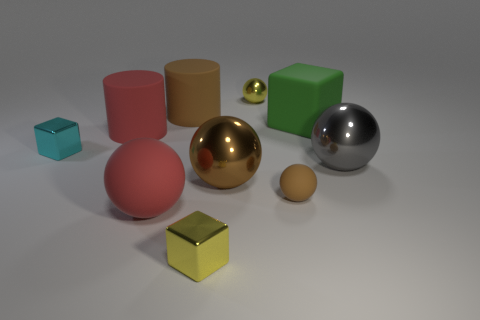Subtract 2 spheres. How many spheres are left? 3 Subtract all gray spheres. How many spheres are left? 4 Subtract all large matte balls. How many balls are left? 4 Subtract all purple balls. Subtract all brown cubes. How many balls are left? 5 Subtract all cubes. How many objects are left? 7 Add 5 cyan objects. How many cyan objects exist? 6 Subtract 0 blue cylinders. How many objects are left? 10 Subtract all matte blocks. Subtract all metallic spheres. How many objects are left? 6 Add 6 tiny yellow balls. How many tiny yellow balls are left? 7 